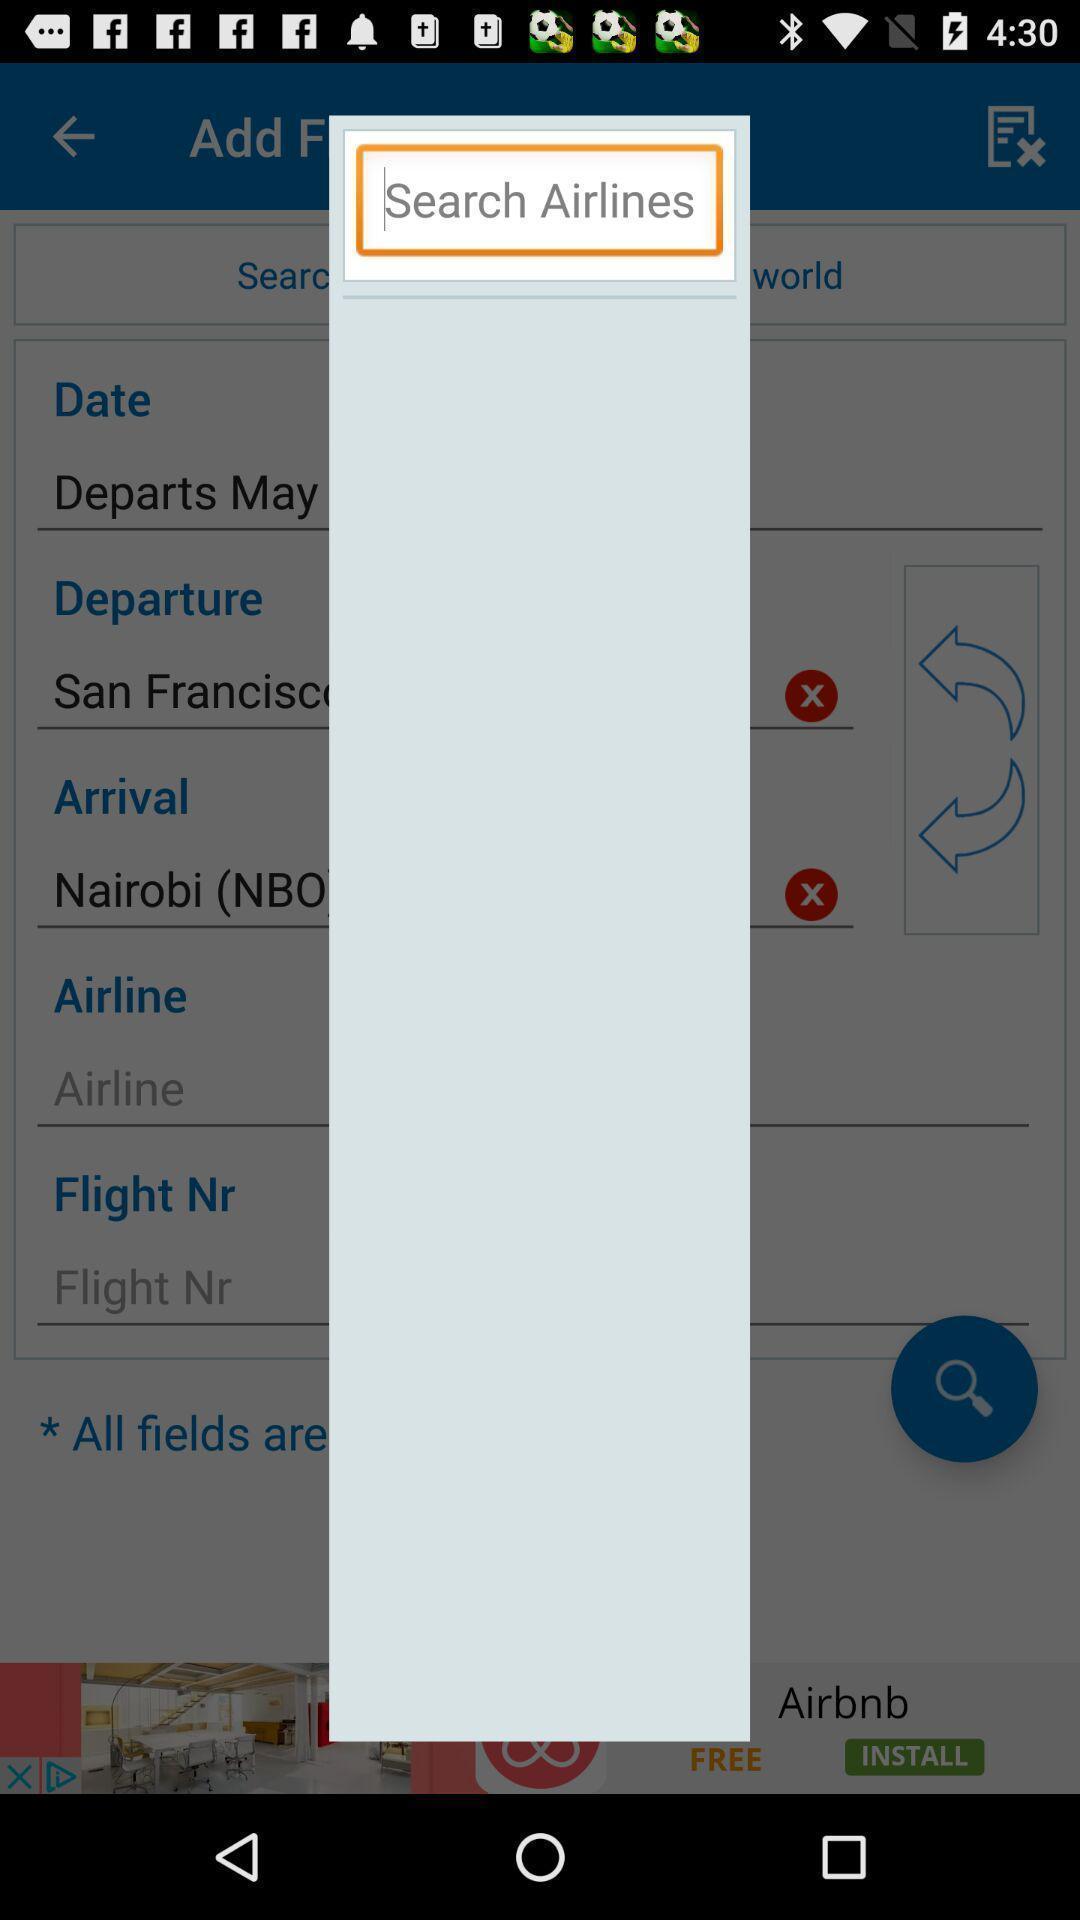Provide a textual representation of this image. Pop-up showing search icon to find airlines. 